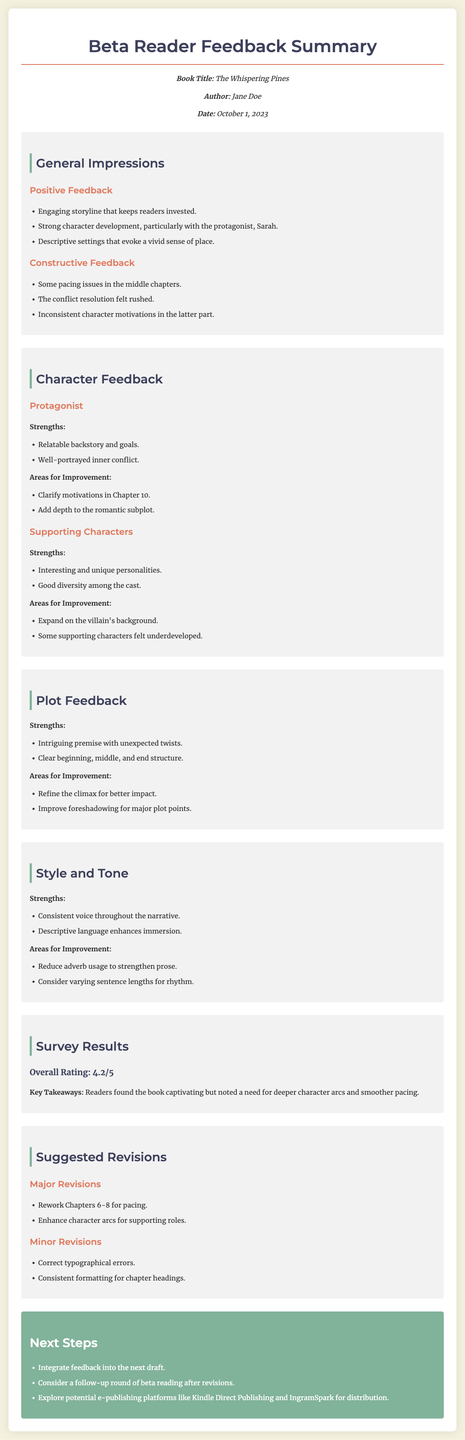What is the title of the book? The title is presented clearly in the document's header section.
Answer: The Whispering Pines Who is the author? The author's name is mentioned in the meta-info section of the document.
Answer: Jane Doe What is the overall rating given by the beta readers? The overall rating is provided in the survey results section.
Answer: 4.2/5 What are the strengths of the protagonist? The strengths are listed in the character feedback for the protagonist.
Answer: Relatable backstory and goals What areas for improvement are suggested for the supporting characters? Areas for improvement are outlined in the character feedback section for supporting characters.
Answer: Expand on the villain's background What is one major revision suggested? Major revisions are specifically listed under the suggested revisions section.
Answer: Rework Chapters 6-8 for pacing What was a key takeaway from the survey results? The key takeaway summarizes the readers' opinions found in the survey results section.
Answer: Need for deeper character arcs and smoother pacing What is a minor revision suggested in the document? Minor revisions are listed and categorized in the suggested revisions section.
Answer: Correct typographical errors What should the author consider as a next step? The next steps are outlined at the end of the document, indicating actions for the author.
Answer: Integrate feedback into the next draft 